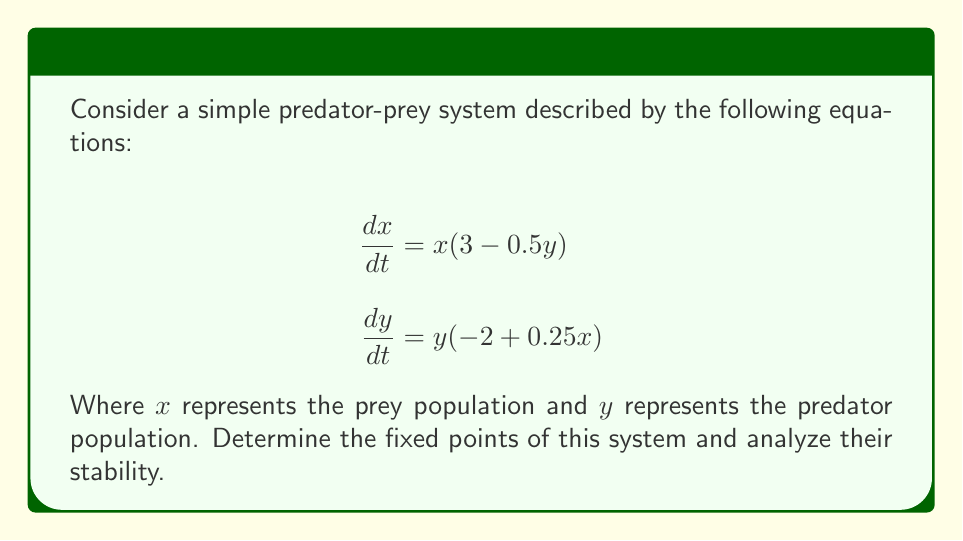Show me your answer to this math problem. 1. Find the fixed points:
   Set $\frac{dx}{dt} = 0$ and $\frac{dy}{dt} = 0$:
   
   $$x(3 - 0.5y) = 0$$
   $$y(-2 + 0.25x) = 0$$

   Solving these equations:
   a) $(x, y) = (0, 0)$
   b) $(x, y) = (8, 6)$

2. Analyze stability:
   Calculate the Jacobian matrix:
   
   $$J = \begin{bmatrix}
   \frac{\partial}{\partial x}(x(3-0.5y)) & \frac{\partial}{\partial y}(x(3-0.5y)) \\
   \frac{\partial}{\partial x}(y(-2+0.25x)) & \frac{\partial}{\partial y}(y(-2+0.25x))
   \end{bmatrix}$$

   $$J = \begin{bmatrix}
   3-0.5y & -0.5x \\
   0.25y & -2+0.25x
   \end{bmatrix}$$

3. Evaluate Jacobian at fixed points:
   a) For $(0, 0)$:
      $$J_{(0,0)} = \begin{bmatrix}
      3 & 0 \\
      0 & -2
      \end{bmatrix}$$
      Eigenvalues: $\lambda_1 = 3$, $\lambda_2 = -2$
      Since $\lambda_1 > 0$, this point is unstable (saddle point).

   b) For $(8, 6)$:
      $$J_{(8,6)} = \begin{bmatrix}
      0 & -4 \\
      1.5 & 0
      \end{bmatrix}$$
      Characteristic equation: $\lambda^2 + 6 = 0$
      Eigenvalues: $\lambda = \pm i\sqrt{6}$
      Since eigenvalues are purely imaginary, this point is a center (neutrally stable).
Answer: $(0,0)$ unstable; $(8,6)$ neutrally stable 